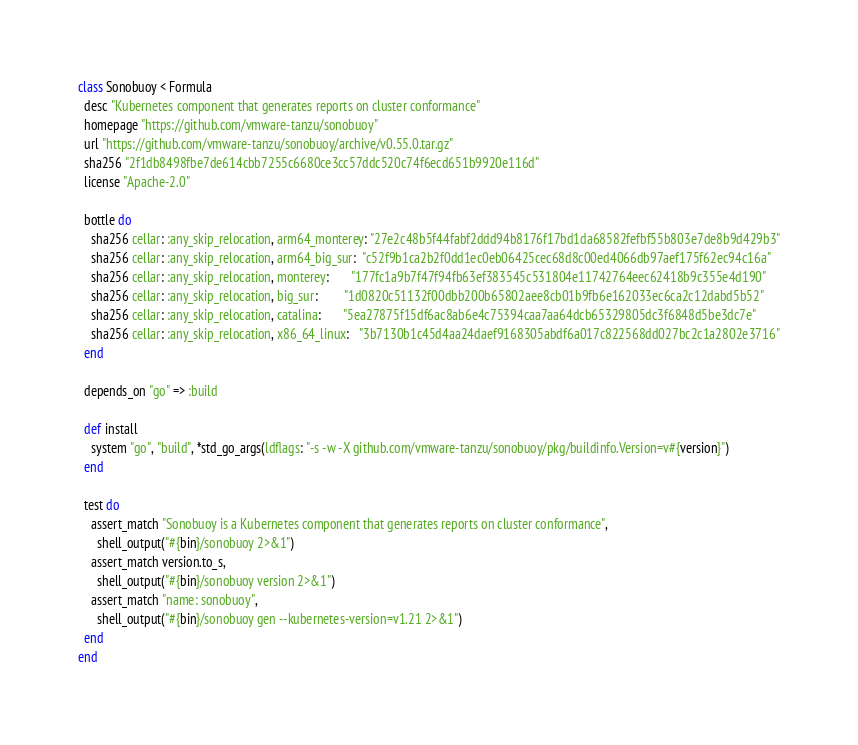Convert code to text. <code><loc_0><loc_0><loc_500><loc_500><_Ruby_>class Sonobuoy < Formula
  desc "Kubernetes component that generates reports on cluster conformance"
  homepage "https://github.com/vmware-tanzu/sonobuoy"
  url "https://github.com/vmware-tanzu/sonobuoy/archive/v0.55.0.tar.gz"
  sha256 "2f1db8498fbe7de614cbb7255c6680ce3cc57ddc520c74f6ecd651b9920e116d"
  license "Apache-2.0"

  bottle do
    sha256 cellar: :any_skip_relocation, arm64_monterey: "27e2c48b5f44fabf2ddd94b8176f17bd1da68582fefbf55b803e7de8b9d429b3"
    sha256 cellar: :any_skip_relocation, arm64_big_sur:  "c52f9b1ca2b2f0dd1ec0eb06425cec68d8c00ed4066db97aef175f62ec94c16a"
    sha256 cellar: :any_skip_relocation, monterey:       "177fc1a9b7f47f94fb63ef383545c531804e11742764eec62418b9c355e4d190"
    sha256 cellar: :any_skip_relocation, big_sur:        "1d0820c51132f00dbb200b65802aee8cb01b9fb6e162033ec6ca2c12dabd5b52"
    sha256 cellar: :any_skip_relocation, catalina:       "5ea27875f15df6ac8ab6e4c75394caa7aa64dcb65329805dc3f6848d5be3dc7e"
    sha256 cellar: :any_skip_relocation, x86_64_linux:   "3b7130b1c45d4aa24daef9168305abdf6a017c822568dd027bc2c1a2802e3716"
  end

  depends_on "go" => :build

  def install
    system "go", "build", *std_go_args(ldflags: "-s -w -X github.com/vmware-tanzu/sonobuoy/pkg/buildinfo.Version=v#{version}")
  end

  test do
    assert_match "Sonobuoy is a Kubernetes component that generates reports on cluster conformance",
      shell_output("#{bin}/sonobuoy 2>&1")
    assert_match version.to_s,
      shell_output("#{bin}/sonobuoy version 2>&1")
    assert_match "name: sonobuoy",
      shell_output("#{bin}/sonobuoy gen --kubernetes-version=v1.21 2>&1")
  end
end
</code> 